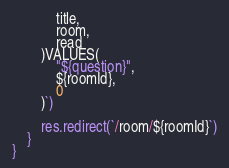<code> <loc_0><loc_0><loc_500><loc_500><_JavaScript_>            title,
            room,
            read
        )VALUES(
            "${question}",
            ${roomId},
            0
        )`)

        res.redirect(`/room/${roomId}`)
    }
}</code> 